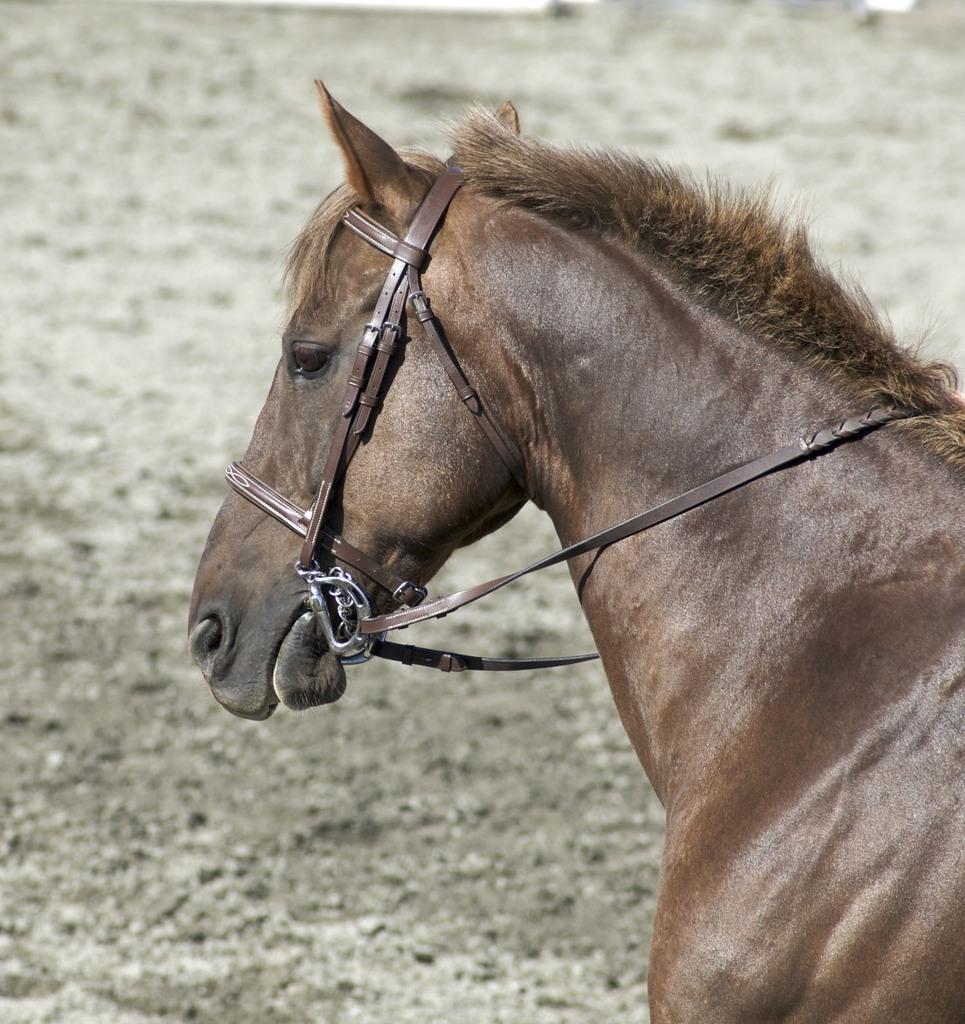Please provide a concise description of this image. In the image there is a horse and the background of the horse is blur. 